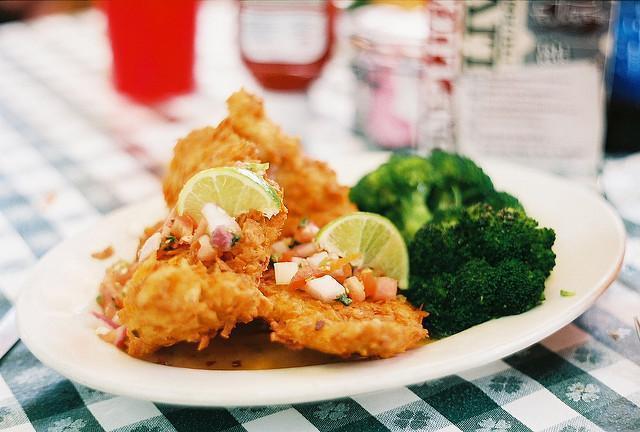What citrus fruit is atop the fried food?
Indicate the correct response by choosing from the four available options to answer the question.
Options: Lime, orange, grapefruit, lemon. Lime. 